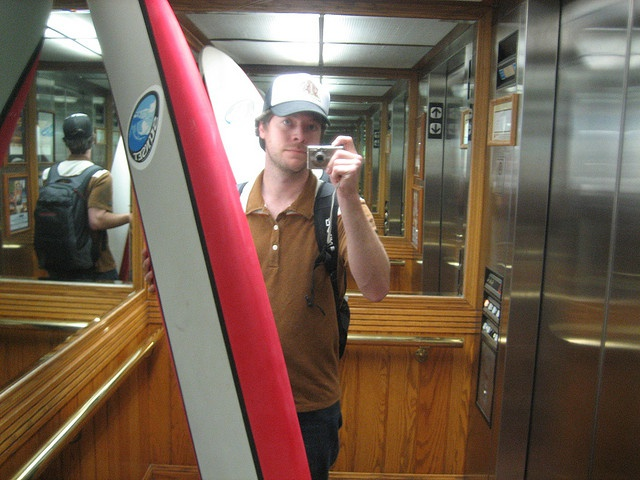Describe the objects in this image and their specific colors. I can see surfboard in darkgreen, darkgray, brown, salmon, and black tones, people in darkgreen, black, maroon, gray, and brown tones, surfboard in darkgreen, white, darkgray, gray, and lightpink tones, backpack in darkgreen, black, gray, and purple tones, and people in darkgreen, black, gray, and white tones in this image. 